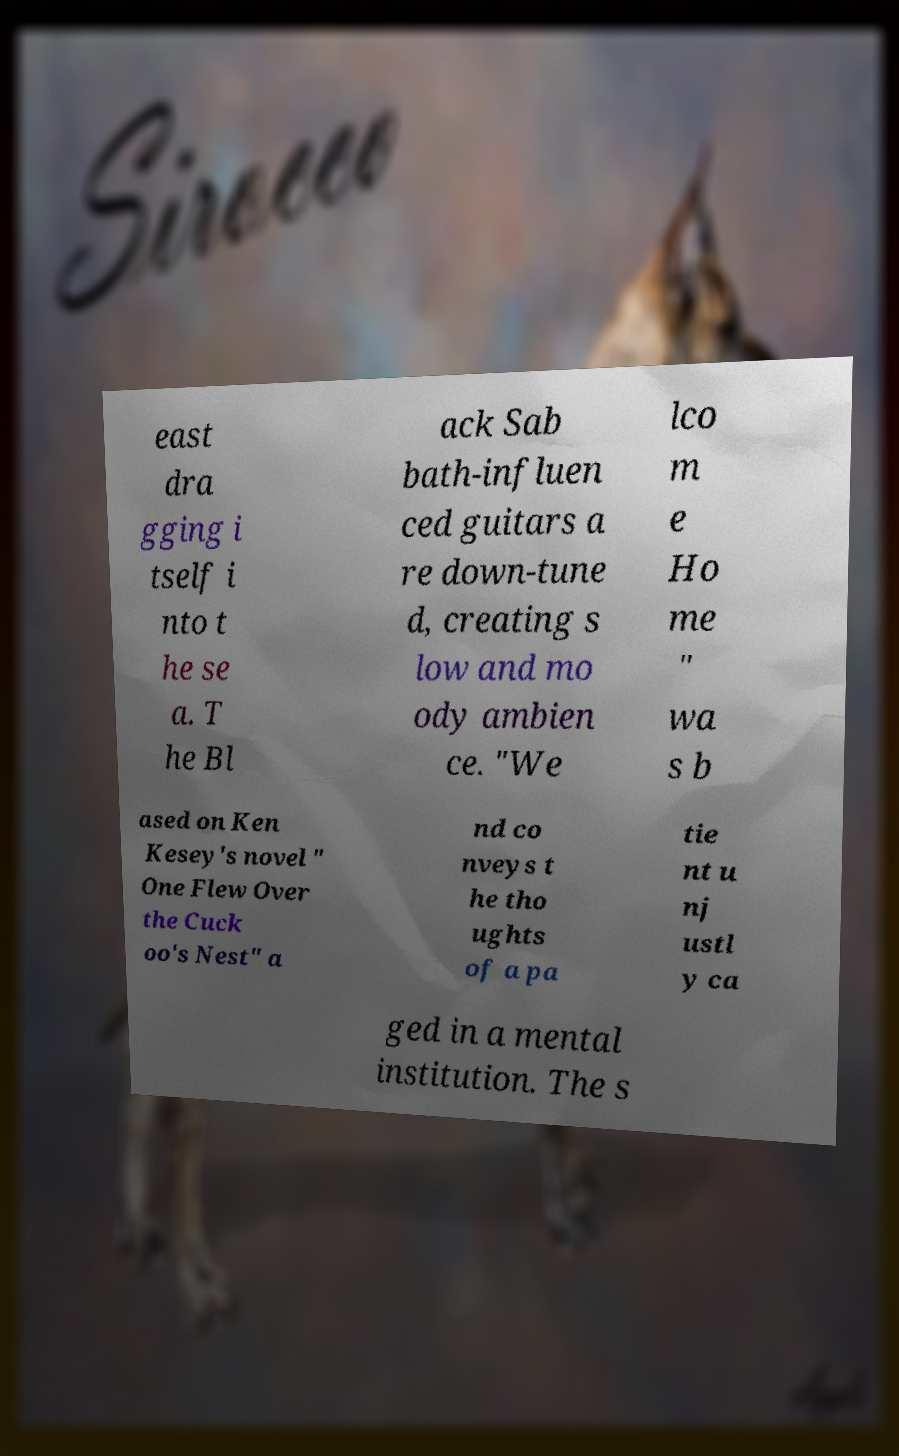For documentation purposes, I need the text within this image transcribed. Could you provide that? east dra gging i tself i nto t he se a. T he Bl ack Sab bath-influen ced guitars a re down-tune d, creating s low and mo ody ambien ce. "We lco m e Ho me " wa s b ased on Ken Kesey's novel " One Flew Over the Cuck oo's Nest" a nd co nveys t he tho ughts of a pa tie nt u nj ustl y ca ged in a mental institution. The s 